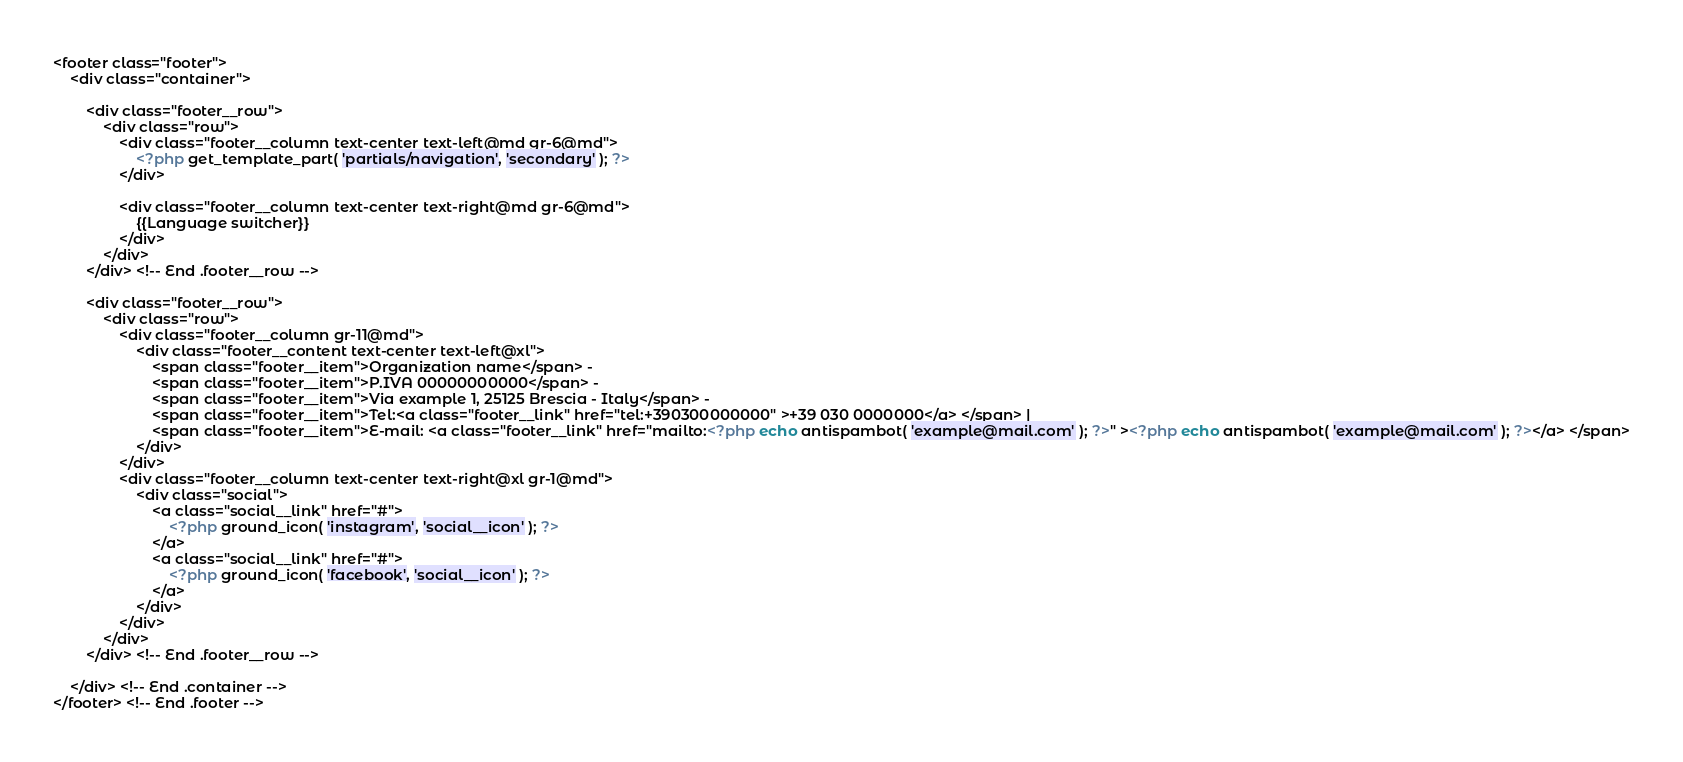Convert code to text. <code><loc_0><loc_0><loc_500><loc_500><_PHP_><footer class="footer">
	<div class="container">

		<div class="footer__row">
			<div class="row">
				<div class="footer__column text-center text-left@md gr-6@md">
					<?php get_template_part( 'partials/navigation', 'secondary' ); ?>
				</div>

				<div class="footer__column text-center text-right@md gr-6@md">
					{{Language switcher}}
				</div>
			</div>
		</div> <!-- End .footer__row -->

		<div class="footer__row">
			<div class="row">
				<div class="footer__column gr-11@md">
					<div class="footer__content text-center text-left@xl">
						<span class="footer__item">Organization name</span> -
						<span class="footer__item">P.IVA 00000000000</span> -
						<span class="footer__item">Via example 1, 25125 Brescia - Italy</span> -
						<span class="footer__item">Tel:<a class="footer__link" href="tel:+390300000000" >+39 030 0000000</a> </span> |
						<span class="footer__item">E-mail: <a class="footer__link" href="mailto:<?php echo antispambot( 'example@mail.com' ); ?>" ><?php echo antispambot( 'example@mail.com' ); ?></a> </span>
					</div>
				</div>
				<div class="footer__column text-center text-right@xl gr-1@md">
					<div class="social">
						<a class="social__link" href="#">
							<?php ground_icon( 'instagram', 'social__icon' ); ?>
						</a>
						<a class="social__link" href="#">
							<?php ground_icon( 'facebook', 'social__icon' ); ?>
						</a>
					</div>
				</div>
			</div>
		</div> <!-- End .footer__row -->

	</div> <!-- End .container -->
</footer> <!-- End .footer -->
</code> 